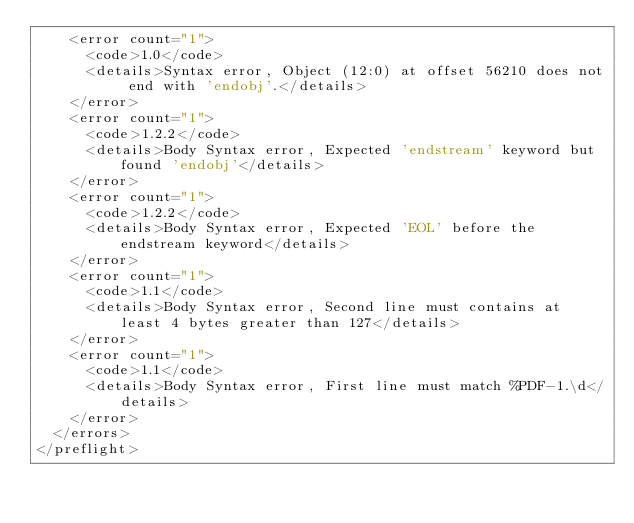<code> <loc_0><loc_0><loc_500><loc_500><_XML_>    <error count="1">
      <code>1.0</code>
      <details>Syntax error, Object (12:0) at offset 56210 does not end with 'endobj'.</details>
    </error>
    <error count="1">
      <code>1.2.2</code>
      <details>Body Syntax error, Expected 'endstream' keyword but found 'endobj'</details>
    </error>
    <error count="1">
      <code>1.2.2</code>
      <details>Body Syntax error, Expected 'EOL' before the endstream keyword</details>
    </error>
    <error count="1">
      <code>1.1</code>
      <details>Body Syntax error, Second line must contains at least 4 bytes greater than 127</details>
    </error>
    <error count="1">
      <code>1.1</code>
      <details>Body Syntax error, First line must match %PDF-1.\d</details>
    </error>
  </errors>
</preflight>
</code> 